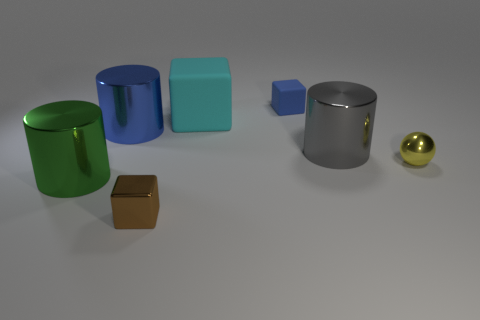Subtract all large cyan matte cubes. How many cubes are left? 2 Subtract 1 blocks. How many blocks are left? 2 Add 2 tiny brown shiny blocks. How many objects exist? 9 Subtract all cylinders. How many objects are left? 4 Add 6 blue rubber things. How many blue rubber things exist? 7 Subtract 0 red cylinders. How many objects are left? 7 Subtract all brown spheres. Subtract all red cubes. How many spheres are left? 1 Subtract all gray cubes. How many green cylinders are left? 1 Subtract all large gray shiny things. Subtract all big rubber cubes. How many objects are left? 5 Add 6 large gray metal cylinders. How many large gray metal cylinders are left? 7 